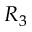<formula> <loc_0><loc_0><loc_500><loc_500>R _ { 3 }</formula> 